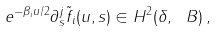<formula> <loc_0><loc_0><loc_500><loc_500>e ^ { - \beta _ { i } u / 2 } \partial _ { s } ^ { j } \tilde { f } _ { i } ( u , s ) \in H ^ { 2 } ( \delta , \ B ) \, ,</formula> 